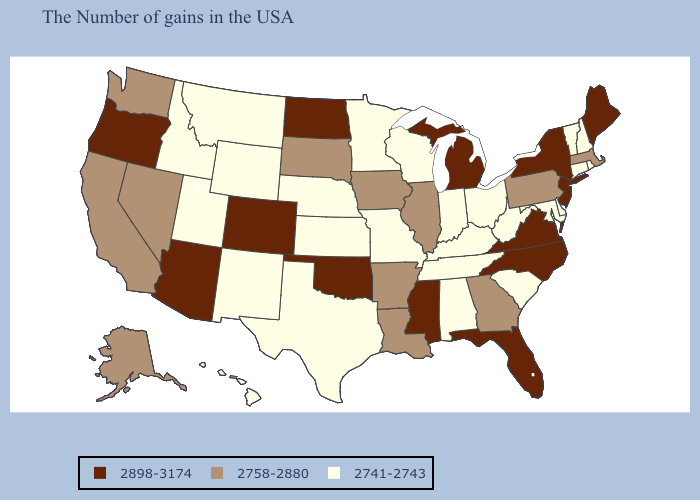Does Washington have the highest value in the USA?
Concise answer only. No. What is the lowest value in the Northeast?
Give a very brief answer. 2741-2743. Among the states that border Maryland , does Virginia have the highest value?
Concise answer only. Yes. What is the value of Oklahoma?
Be succinct. 2898-3174. Does the map have missing data?
Write a very short answer. No. What is the value of Arkansas?
Concise answer only. 2758-2880. Among the states that border New Hampshire , which have the highest value?
Concise answer only. Maine. Does the first symbol in the legend represent the smallest category?
Answer briefly. No. What is the highest value in the South ?
Answer briefly. 2898-3174. What is the value of Idaho?
Answer briefly. 2741-2743. Does Mississippi have the same value as South Dakota?
Short answer required. No. What is the highest value in the West ?
Short answer required. 2898-3174. What is the value of Delaware?
Concise answer only. 2741-2743. What is the lowest value in the USA?
Concise answer only. 2741-2743. Which states hav the highest value in the South?
Keep it brief. Virginia, North Carolina, Florida, Mississippi, Oklahoma. 